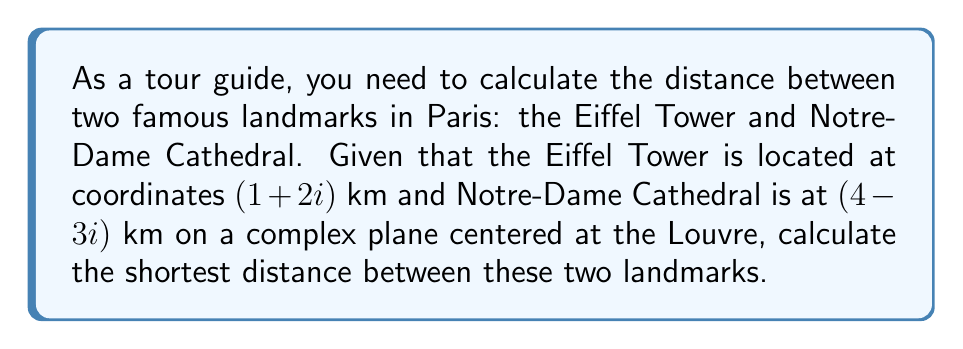Solve this math problem. To find the distance between two points on a complex plane, we can use the absolute value of the difference between the two complex numbers. Let's approach this step-by-step:

1) Let $z_1 = 1 + 2i$ (Eiffel Tower) and $z_2 = 4 - 3i$ (Notre-Dame Cathedral)

2) The difference between these points is:
   $z_2 - z_1 = (4 - 3i) - (1 + 2i) = 3 - 5i$

3) The distance is the absolute value (or modulus) of this difference:
   $d = |z_2 - z_1| = |3 - 5i|$

4) For a complex number $a + bi$, the absolute value is given by $\sqrt{a^2 + b^2}$

5) Therefore:
   $d = \sqrt{3^2 + (-5)^2} = \sqrt{9 + 25} = \sqrt{34}$

6) $\sqrt{34} \approx 5.83$ km

Thus, the shortest distance between the Eiffel Tower and Notre-Dame Cathedral is $\sqrt{34}$ km or approximately 5.83 km.
Answer: $\sqrt{34}$ km 